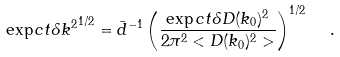Convert formula to latex. <formula><loc_0><loc_0><loc_500><loc_500>\exp c t { \delta k ^ { 2 } } ^ { 1 / 2 } = \bar { d } ^ { - 1 } \left ( \frac { \exp c t { \delta D ( k _ { 0 } ) ^ { 2 } } } { 2 \pi ^ { 2 } < D ( k _ { 0 } ) ^ { 2 } > } \right ) ^ { 1 / 2 } \ \ .</formula> 